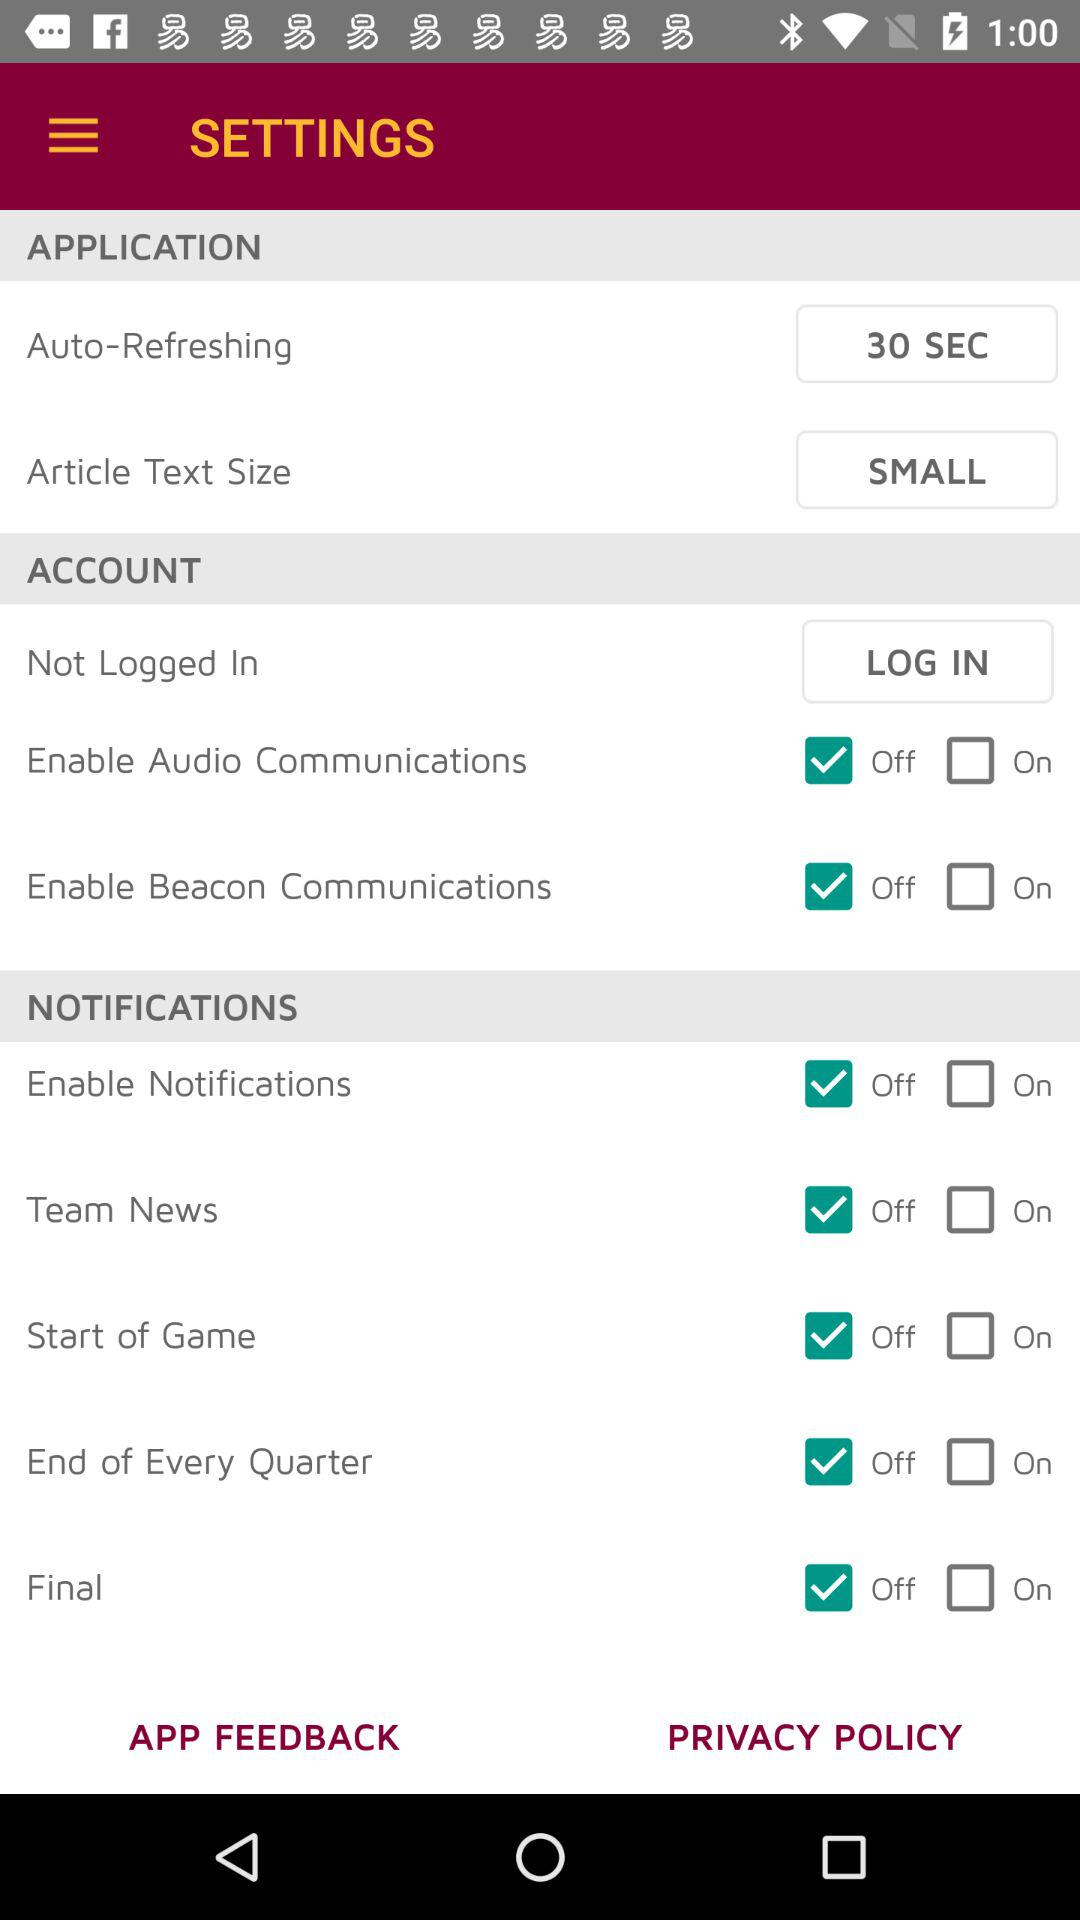What is the setting for auto-refreshing? The setting is "30 SEC". 